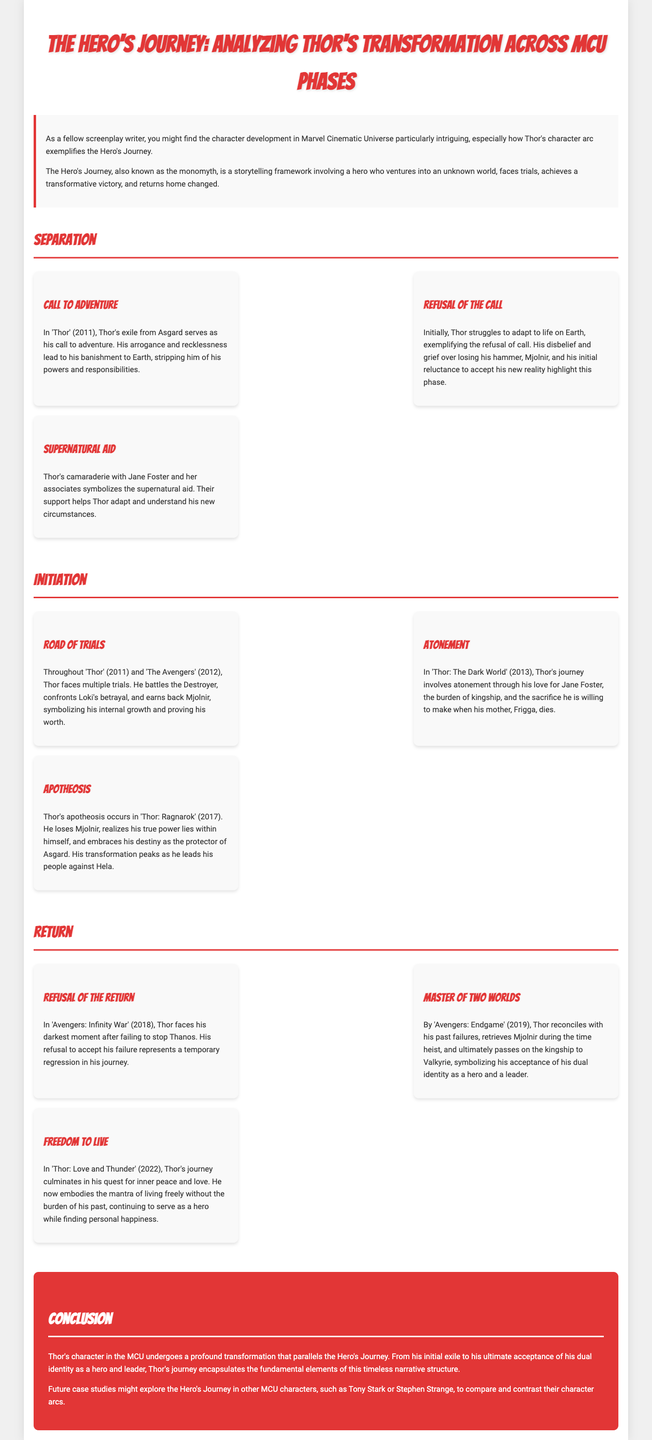what is the title of the case study? The title is presented at the top of the document, summarizing the focus on Thor's transformation in the MCU.
Answer: The Hero's Journey: Analyzing Thor's Transformation Across MCU Phases which film marks Thor's exile from Asgard? The document notes Thor's exile from Asgard as the pivotal moment in the first phase of his journey, which occurs in the first film.
Answer: Thor what is the name of Thor's hammer? The document states that Thor's hammer plays a significant role in his identity and journey.
Answer: Mjolnir what phase covers Thor's apotheosis? The document categorizes Thor's apotheosis as occurring within a specific phase of his journey in the MCU.
Answer: Thor: Ragnarok in which film does Thor face his darkest moment? The text highlights a pivotal point in Thor's character arc where he confronts significant failure.
Answer: Avengers: Infinity War what does Thor ultimately seek in 'Thor: Love and Thunder'? The conclusion regarding Thor's journey indicates a desire for a particular state of being or mindset that shapes his character.
Answer: inner peace how many phases are outlined in Thor's Hero's Journey? The document organizes Thor's journey into distinct phases, each containing specific steps.
Answer: Three who does Thor pass kingship to in 'Avengers: Endgame'? The document explicitly identifies the character who receives leadership from Thor at a critical moment in his journey.
Answer: Valkyrie 